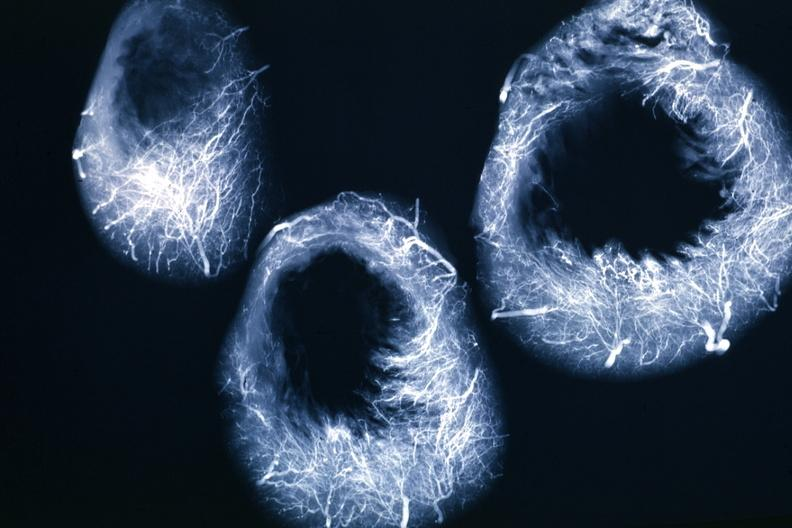s cardiovascular present?
Answer the question using a single word or phrase. Yes 